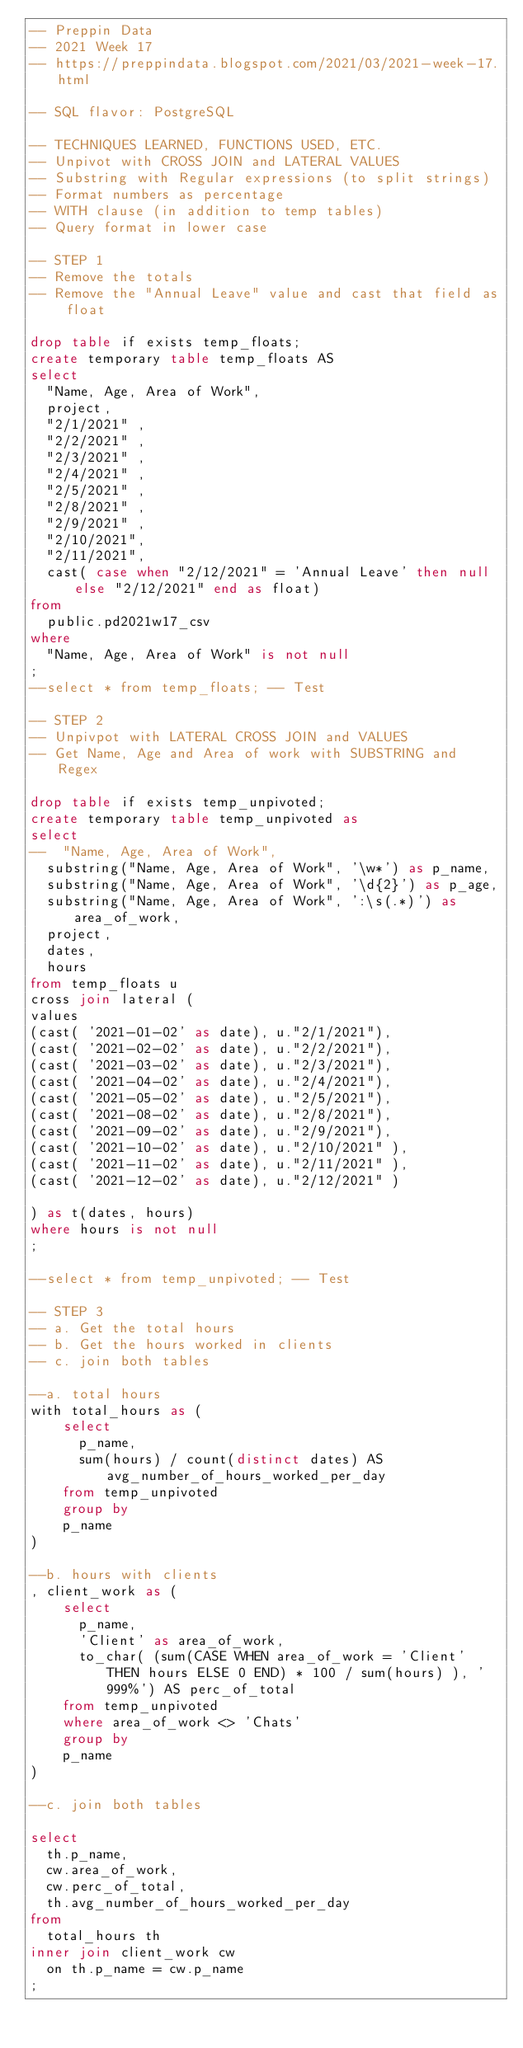<code> <loc_0><loc_0><loc_500><loc_500><_SQL_>-- Preppin Data
-- 2021 Week 17
-- https://preppindata.blogspot.com/2021/03/2021-week-17.html

-- SQL flavor: PostgreSQL

-- TECHNIQUES LEARNED, FUNCTIONS USED, ETC.
-- Unpivot with CROSS JOIN and LATERAL VALUES
-- Substring with Regular expressions (to split strings)
-- Format numbers as percentage
-- WITH clause (in addition to temp tables)
-- Query format in lower case

-- STEP 1
-- Remove the totals
-- Remove the "Annual Leave" value and cast that field as float

drop table if exists temp_floats;
create temporary table temp_floats AS
select
	"Name, Age, Area of Work",
	project,
	"2/1/2021" ,
	"2/2/2021" ,
	"2/3/2021" ,
	"2/4/2021" ,
	"2/5/2021" ,
	"2/8/2021" ,
	"2/9/2021" ,
	"2/10/2021",
	"2/11/2021",
	cast( case when "2/12/2021" = 'Annual Leave' then null else "2/12/2021" end as float)
from
	public.pd2021w17_csv
where 
	"Name, Age, Area of Work" is not null
;
--select * from temp_floats; -- Test

-- STEP 2
-- Unpivpot with LATERAL CROSS JOIN and VALUES
-- Get Name, Age and Area of work with SUBSTRING and Regex

drop table if exists temp_unpivoted;
create temporary table temp_unpivoted as 
select 
--	"Name, Age, Area of Work",
	substring("Name, Age, Area of Work", '\w*') as p_name,
	substring("Name, Age, Area of Work", '\d{2}') as p_age,
	substring("Name, Age, Area of Work", ':\s(.*)') as area_of_work,
	project,
	dates,
	hours
from temp_floats u
cross join lateral (
values 
(cast( '2021-01-02' as date), u."2/1/2021"),
(cast( '2021-02-02' as date), u."2/2/2021"),
(cast( '2021-03-02' as date), u."2/3/2021"),
(cast( '2021-04-02' as date), u."2/4/2021"),
(cast( '2021-05-02' as date), u."2/5/2021"),
(cast( '2021-08-02' as date), u."2/8/2021"),
(cast( '2021-09-02' as date), u."2/9/2021"),
(cast( '2021-10-02' as date), u."2/10/2021" ),
(cast( '2021-11-02' as date), u."2/11/2021" ),
(cast( '2021-12-02' as date), u."2/12/2021" )

) as t(dates, hours)
where hours is not null
;

--select * from temp_unpivoted; -- Test

-- STEP 3
-- a. Get the total hours
-- b. Get the hours worked in clients
-- c. join both tables

--a. total hours
with total_hours as (
		select 
			p_name,
			sum(hours) / count(distinct dates) AS avg_number_of_hours_worked_per_day
		from temp_unpivoted
		group by
		p_name
)

--b. hours with clients
, client_work as (
		select 
			p_name,
			'Client' as area_of_work,
			to_char( (sum(CASE WHEN area_of_work = 'Client' THEN hours ELSE 0 END) * 100 / sum(hours) ), '999%') AS perc_of_total
		from temp_unpivoted
		where area_of_work <> 'Chats'
		group by
		p_name
)

--c. join both tables

select
	th.p_name,
	cw.area_of_work,
	cw.perc_of_total,
	th.avg_number_of_hours_worked_per_day
from
	total_hours th
inner join client_work cw 
	on th.p_name = cw.p_name
;
</code> 